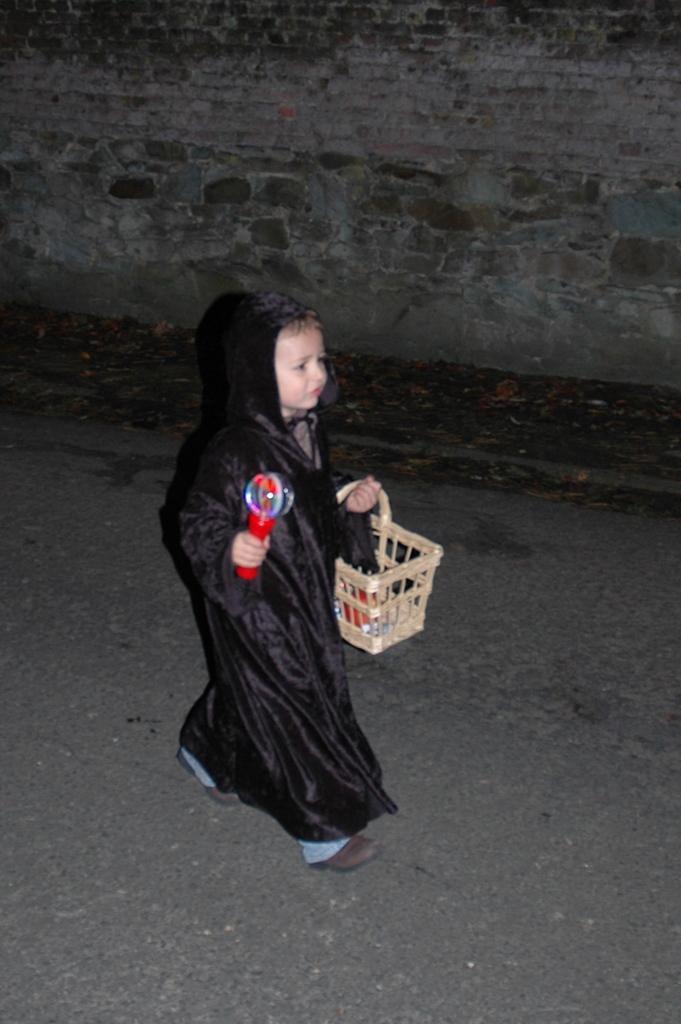Please provide a concise description of this image. Here in this picture we can see a child in a black colored dress walking on the road over there and she is holding a basket in one hand and a toy in another hand and beside her we can see a wall present over there. 